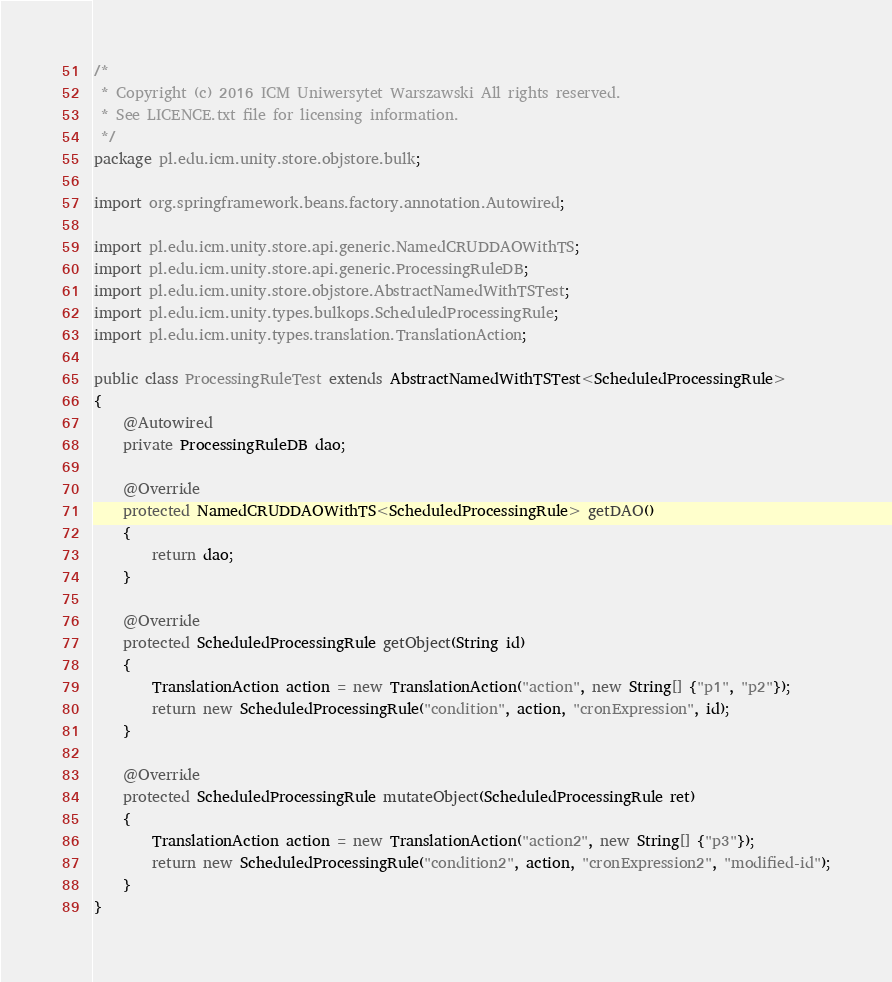<code> <loc_0><loc_0><loc_500><loc_500><_Java_>/*
 * Copyright (c) 2016 ICM Uniwersytet Warszawski All rights reserved.
 * See LICENCE.txt file for licensing information.
 */
package pl.edu.icm.unity.store.objstore.bulk;

import org.springframework.beans.factory.annotation.Autowired;

import pl.edu.icm.unity.store.api.generic.NamedCRUDDAOWithTS;
import pl.edu.icm.unity.store.api.generic.ProcessingRuleDB;
import pl.edu.icm.unity.store.objstore.AbstractNamedWithTSTest;
import pl.edu.icm.unity.types.bulkops.ScheduledProcessingRule;
import pl.edu.icm.unity.types.translation.TranslationAction;

public class ProcessingRuleTest extends AbstractNamedWithTSTest<ScheduledProcessingRule>
{
	@Autowired
	private ProcessingRuleDB dao;
	
	@Override
	protected NamedCRUDDAOWithTS<ScheduledProcessingRule> getDAO()
	{
		return dao;
	}

	@Override
	protected ScheduledProcessingRule getObject(String id)
	{
		TranslationAction action = new TranslationAction("action", new String[] {"p1", "p2"});
		return new ScheduledProcessingRule("condition", action, "cronExpression", id);
	}

	@Override
	protected ScheduledProcessingRule mutateObject(ScheduledProcessingRule ret)
	{
		TranslationAction action = new TranslationAction("action2", new String[] {"p3"});
		return new ScheduledProcessingRule("condition2", action, "cronExpression2", "modified-id");
	}
}
</code> 